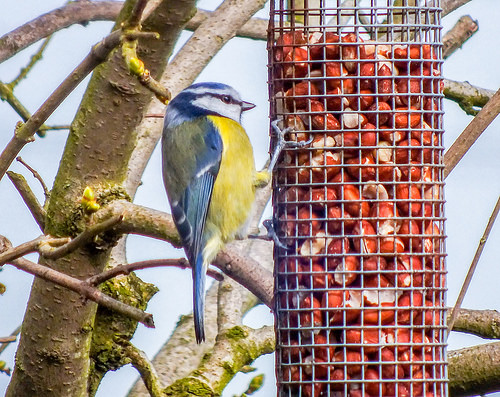<image>
Can you confirm if the bird is on the branch? Yes. Looking at the image, I can see the bird is positioned on top of the branch, with the branch providing support. 